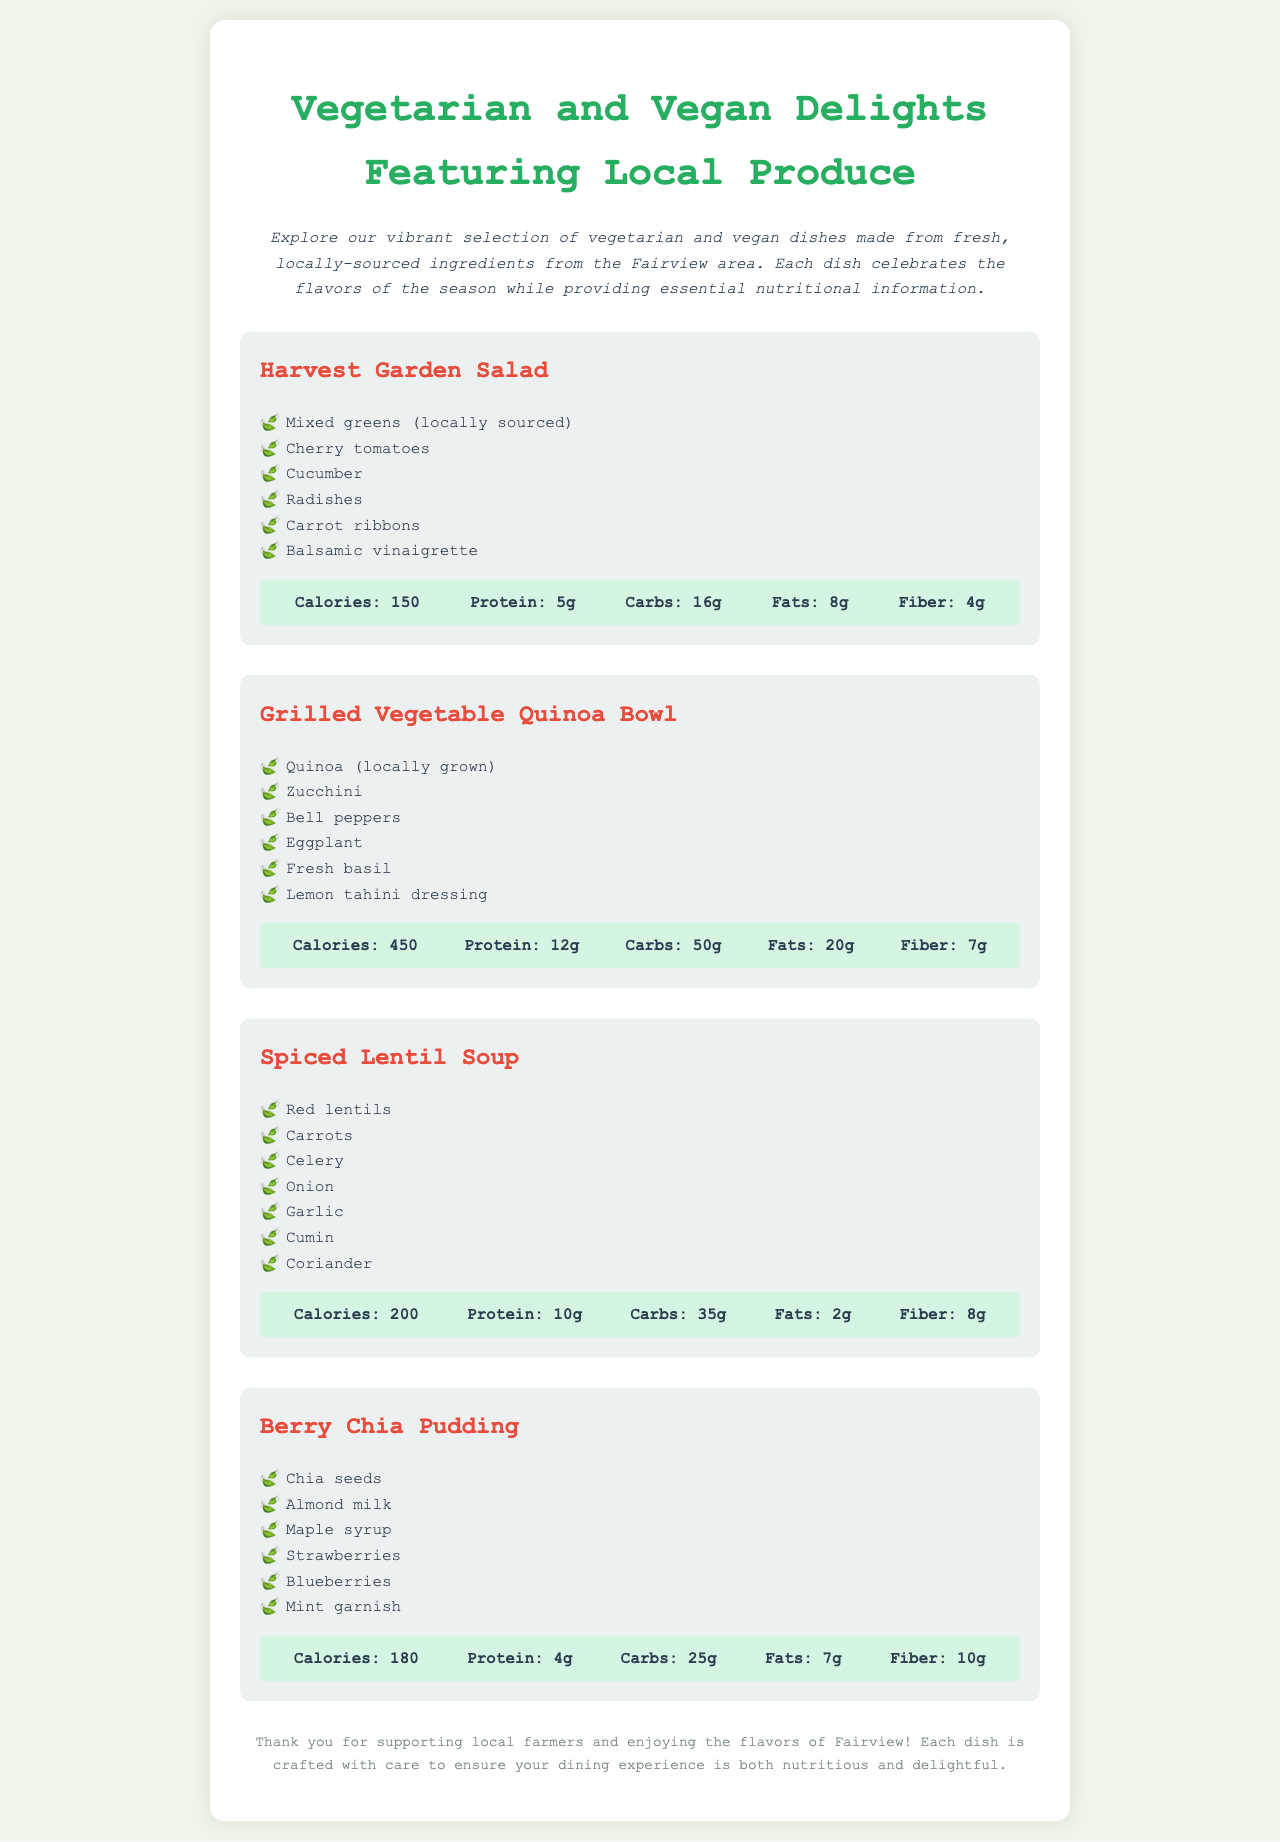What is the title of the menu? The title of the menu is located at the top of the document.
Answer: Vegetarian and Vegan Delights Featuring Local Produce How many dishes are featured in the menu? The number of dishes is determined by counting each distinct dish listed in the document.
Answer: 4 What are the ingredients in the Harvest Garden Salad? Ingredients for the Harvest Garden Salad are listed under that dish in the document.
Answer: Mixed greens, Cherry tomatoes, Cucumber, Radishes, Carrot ribbons, Balsamic vinaigrette What is the calorie count for the Grilled Vegetable Quinoa Bowl? The calorie count is given in the nutritional information for that specific dish.
Answer: 450 Which dish contains red lentils? The dish containing red lentils can be found in the list of dishes in the menu.
Answer: Spiced Lentil Soup What is the main ingredient in the Berry Chia Pudding? The main ingredient is the first item listed under the Berry Chia Pudding dish.
Answer: Chia seeds How much protein does the Spiced Lentil Soup provide? The protein content is provided in the nutritional information for that dish.
Answer: 10g What type of dressing is used in the Grilled Vegetable Quinoa Bowl? The type of dressing is mentioned in the ingredients list for that specific dish.
Answer: Lemon tahini dressing 